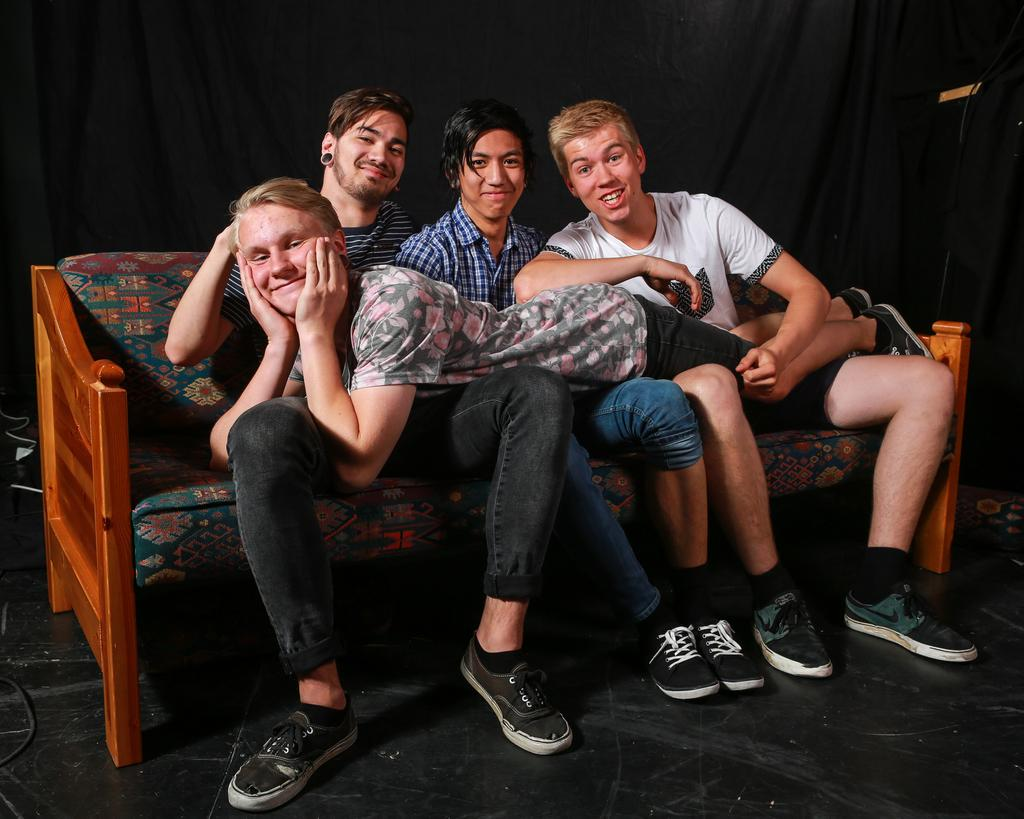What is the main subject of the image? The main subject of the image is a group of persons. Where are the persons located in the image? The persons are in the center of the image. What are the persons doing in the image? The persons are sitting on a sofa and smiling. What can be seen in the background of the image? There is a black color curtain in the background of the image. What type of writing can be seen on the sofa in the image? There is no writing visible on the sofa or anywhere else in the image. 